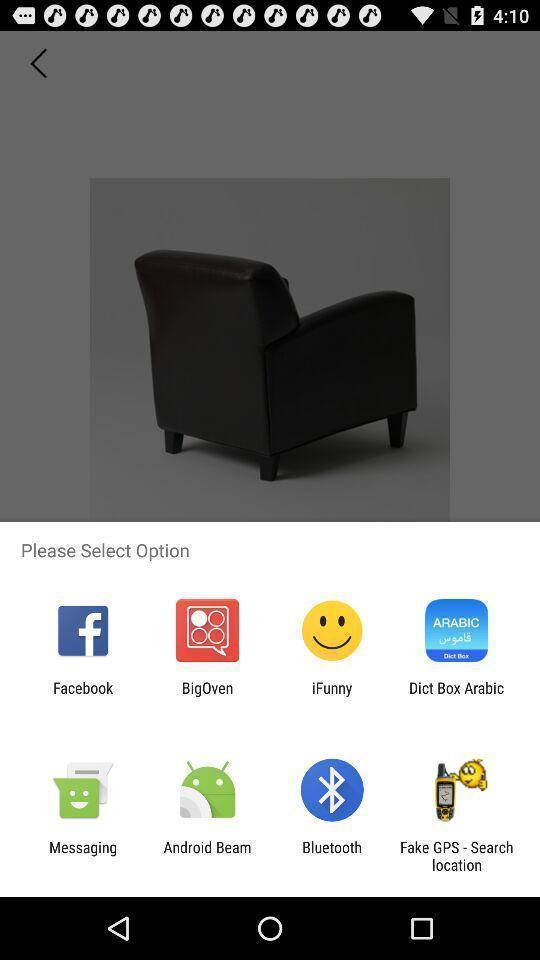Give me a narrative description of this picture. Pop-up showing list of different social app. 